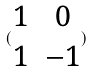Convert formula to latex. <formula><loc_0><loc_0><loc_500><loc_500>( \begin{matrix} 1 & 0 \\ 1 & - 1 \end{matrix} )</formula> 